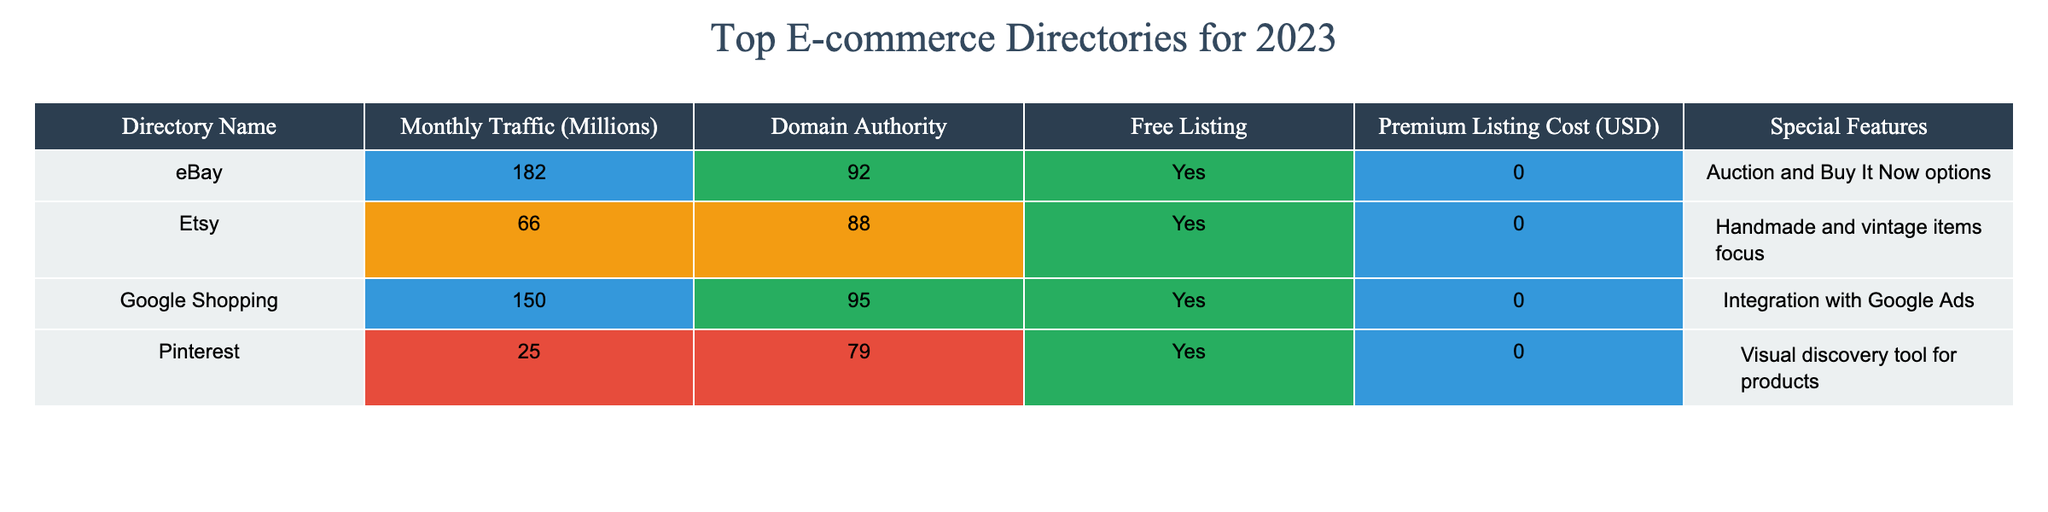What is the monthly traffic for eBay? The table shows eBay has a monthly traffic of 182 million.
Answer: 182 million Which directory has the highest domain authority? According to the table, Google Shopping has the highest domain authority with a score of 95.
Answer: 95 Does Etsy offer a free listing option? The table indicates that Etsy does offer a free listing option, as marked "Yes."
Answer: Yes What is the premium listing cost for Pinterest? The table states that Pinterest has a premium listing cost of 0 USD.
Answer: 0 USD How many directories listed have a monthly traffic above 100 million? From the table, eBay and Google Shopping are the only directories with monthly traffic exceeding 100 million, which totals to 2 directories.
Answer: 2 What is the average monthly traffic of the directories listed? Summing the monthly traffic of all directories (eBay: 182 + Etsy: 66 + Google Shopping: 150 + Pinterest: 25 = 423) gives us 423 million. Dividing that by the number of directories (4) results in an average of 105.75 million.
Answer: 105.75 million Which directory has both high traffic and high domain authority? The table shows that both eBay and Google Shopping have high parameters with eBay having 182 million in traffic and a domain authority of 92, while Google Shopping has 150 million in traffic and a domain authority of 95. Both can be considered as having high traffic and authority.
Answer: eBay and Google Shopping What percentage of the directories listed offer a free listing? Out of four directories listed, all four (100%) offer a free listing option as indicated in the table.
Answer: 100% Which directory offers unique auction options? The table highlights that eBay offers unique auction and "Buy It Now" options.
Answer: eBay What is the total domain authority of all directories listed? Adding the domain authority of all directories (eBay: 92 + Etsy: 88 + Google Shopping: 95 + Pinterest: 79 = 354) results in a total domain authority of 354.
Answer: 354 